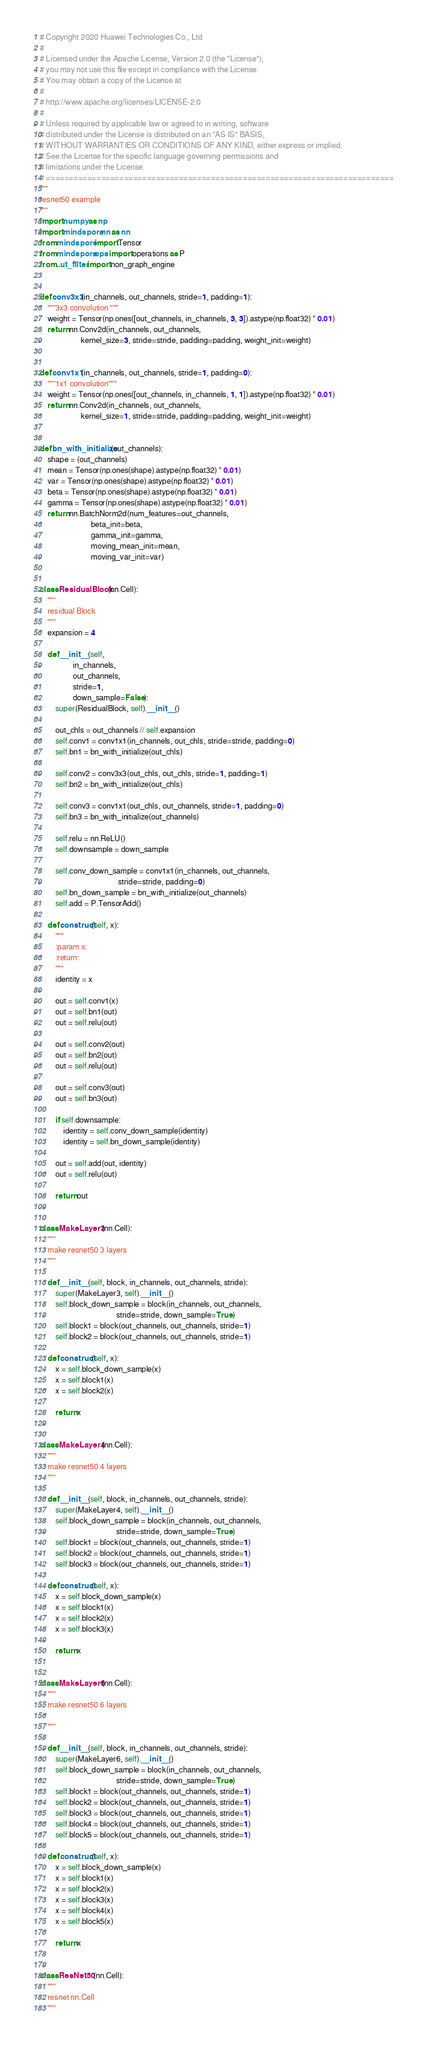<code> <loc_0><loc_0><loc_500><loc_500><_Python_># Copyright 2020 Huawei Technologies Co., Ltd
#
# Licensed under the Apache License, Version 2.0 (the "License");
# you may not use this file except in compliance with the License.
# You may obtain a copy of the License at
#
# http://www.apache.org/licenses/LICENSE-2.0
#
# Unless required by applicable law or agreed to in writing, software
# distributed under the License is distributed on an "AS IS" BASIS,
# WITHOUT WARRANTIES OR CONDITIONS OF ANY KIND, either express or implied.
# See the License for the specific language governing permissions and
# limitations under the License.
# ============================================================================
"""
resnet50 example
"""
import numpy as np
import mindspore.nn as nn
from mindspore import Tensor
from mindspore.ops import operations as P
from ..ut_filter import non_graph_engine


def conv3x3(in_channels, out_channels, stride=1, padding=1):
    """3x3 convolution """
    weight = Tensor(np.ones([out_channels, in_channels, 3, 3]).astype(np.float32) * 0.01)
    return nn.Conv2d(in_channels, out_channels,
                     kernel_size=3, stride=stride, padding=padding, weight_init=weight)


def conv1x1(in_channels, out_channels, stride=1, padding=0):
    """1x1 convolution"""
    weight = Tensor(np.ones([out_channels, in_channels, 1, 1]).astype(np.float32) * 0.01)
    return nn.Conv2d(in_channels, out_channels,
                     kernel_size=1, stride=stride, padding=padding, weight_init=weight)


def bn_with_initialize(out_channels):
    shape = (out_channels)
    mean = Tensor(np.ones(shape).astype(np.float32) * 0.01)
    var = Tensor(np.ones(shape).astype(np.float32) * 0.01)
    beta = Tensor(np.ones(shape).astype(np.float32) * 0.01)
    gamma = Tensor(np.ones(shape).astype(np.float32) * 0.01)
    return nn.BatchNorm2d(num_features=out_channels,
                          beta_init=beta,
                          gamma_init=gamma,
                          moving_mean_init=mean,
                          moving_var_init=var)


class ResidualBlock(nn.Cell):
    """
    residual Block
    """
    expansion = 4

    def __init__(self,
                 in_channels,
                 out_channels,
                 stride=1,
                 down_sample=False):
        super(ResidualBlock, self).__init__()

        out_chls = out_channels // self.expansion
        self.conv1 = conv1x1(in_channels, out_chls, stride=stride, padding=0)
        self.bn1 = bn_with_initialize(out_chls)

        self.conv2 = conv3x3(out_chls, out_chls, stride=1, padding=1)
        self.bn2 = bn_with_initialize(out_chls)

        self.conv3 = conv1x1(out_chls, out_channels, stride=1, padding=0)
        self.bn3 = bn_with_initialize(out_channels)

        self.relu = nn.ReLU()
        self.downsample = down_sample

        self.conv_down_sample = conv1x1(in_channels, out_channels,
                                        stride=stride, padding=0)
        self.bn_down_sample = bn_with_initialize(out_channels)
        self.add = P.TensorAdd()

    def construct(self, x):
        """
        :param x:
        :return:
        """
        identity = x

        out = self.conv1(x)
        out = self.bn1(out)
        out = self.relu(out)

        out = self.conv2(out)
        out = self.bn2(out)
        out = self.relu(out)

        out = self.conv3(out)
        out = self.bn3(out)

        if self.downsample:
            identity = self.conv_down_sample(identity)
            identity = self.bn_down_sample(identity)

        out = self.add(out, identity)
        out = self.relu(out)

        return out


class MakeLayer3(nn.Cell):
    """
    make resnet50 3 layers
    """

    def __init__(self, block, in_channels, out_channels, stride):
        super(MakeLayer3, self).__init__()
        self.block_down_sample = block(in_channels, out_channels,
                                       stride=stride, down_sample=True)
        self.block1 = block(out_channels, out_channels, stride=1)
        self.block2 = block(out_channels, out_channels, stride=1)

    def construct(self, x):
        x = self.block_down_sample(x)
        x = self.block1(x)
        x = self.block2(x)

        return x


class MakeLayer4(nn.Cell):
    """
    make resnet50 4 layers
    """

    def __init__(self, block, in_channels, out_channels, stride):
        super(MakeLayer4, self).__init__()
        self.block_down_sample = block(in_channels, out_channels,
                                       stride=stride, down_sample=True)
        self.block1 = block(out_channels, out_channels, stride=1)
        self.block2 = block(out_channels, out_channels, stride=1)
        self.block3 = block(out_channels, out_channels, stride=1)

    def construct(self, x):
        x = self.block_down_sample(x)
        x = self.block1(x)
        x = self.block2(x)
        x = self.block3(x)

        return x


class MakeLayer6(nn.Cell):
    """
    make resnet50 6 layers

    """

    def __init__(self, block, in_channels, out_channels, stride):
        super(MakeLayer6, self).__init__()
        self.block_down_sample = block(in_channels, out_channels,
                                       stride=stride, down_sample=True)
        self.block1 = block(out_channels, out_channels, stride=1)
        self.block2 = block(out_channels, out_channels, stride=1)
        self.block3 = block(out_channels, out_channels, stride=1)
        self.block4 = block(out_channels, out_channels, stride=1)
        self.block5 = block(out_channels, out_channels, stride=1)

    def construct(self, x):
        x = self.block_down_sample(x)
        x = self.block1(x)
        x = self.block2(x)
        x = self.block3(x)
        x = self.block4(x)
        x = self.block5(x)

        return x


class ResNet50(nn.Cell):
    """
    resnet nn.Cell
    """
</code> 